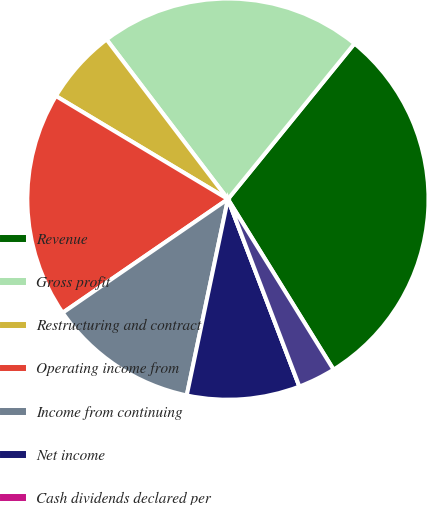<chart> <loc_0><loc_0><loc_500><loc_500><pie_chart><fcel>Revenue<fcel>Gross profit<fcel>Restructuring and contract<fcel>Operating income from<fcel>Income from continuing<fcel>Net income<fcel>Cash dividends declared per<fcel>Income continuing operations<nl><fcel>30.3%<fcel>21.21%<fcel>6.06%<fcel>18.18%<fcel>12.12%<fcel>9.09%<fcel>0.0%<fcel>3.03%<nl></chart> 